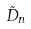Convert formula to latex. <formula><loc_0><loc_0><loc_500><loc_500>\tilde { D } _ { n }</formula> 